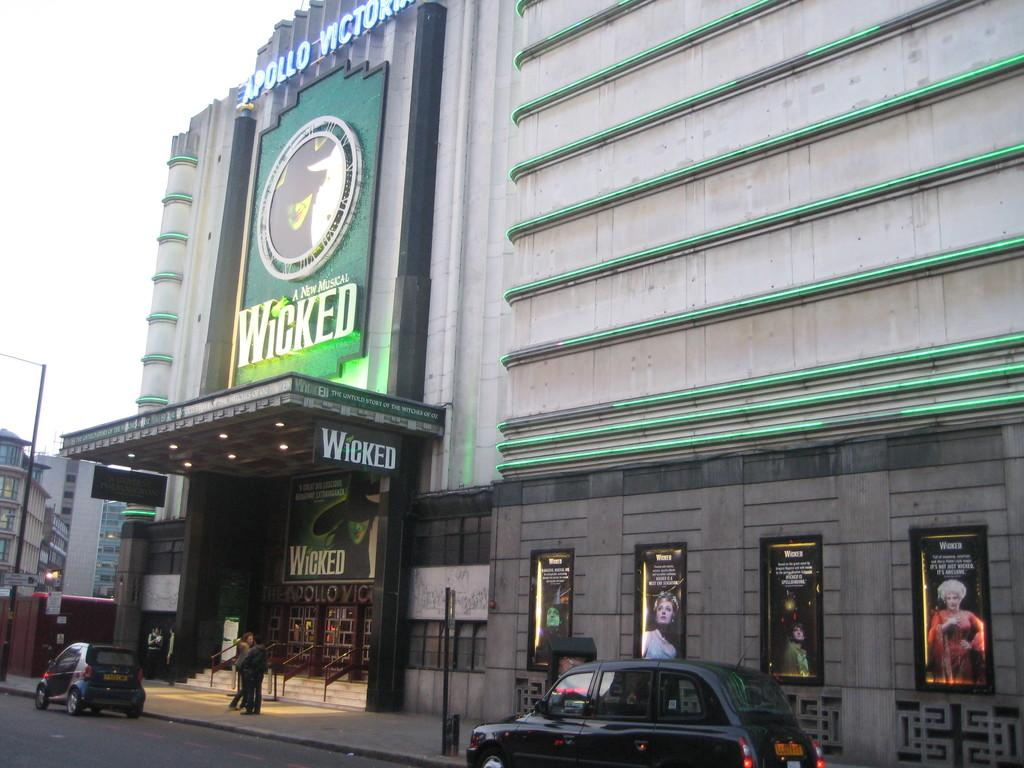<image>
Describe the image concisely. The show Wicked is being advertised at the Apollo. 